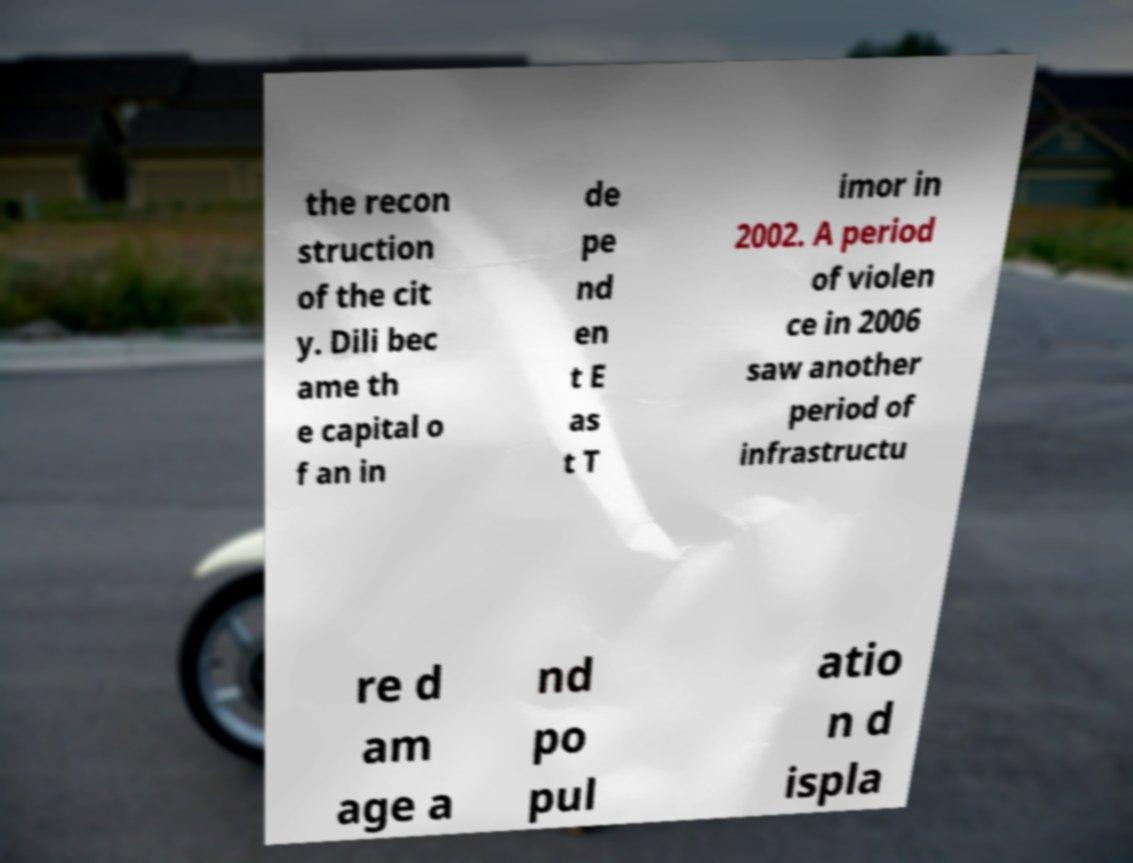Please identify and transcribe the text found in this image. the recon struction of the cit y. Dili bec ame th e capital o f an in de pe nd en t E as t T imor in 2002. A period of violen ce in 2006 saw another period of infrastructu re d am age a nd po pul atio n d ispla 